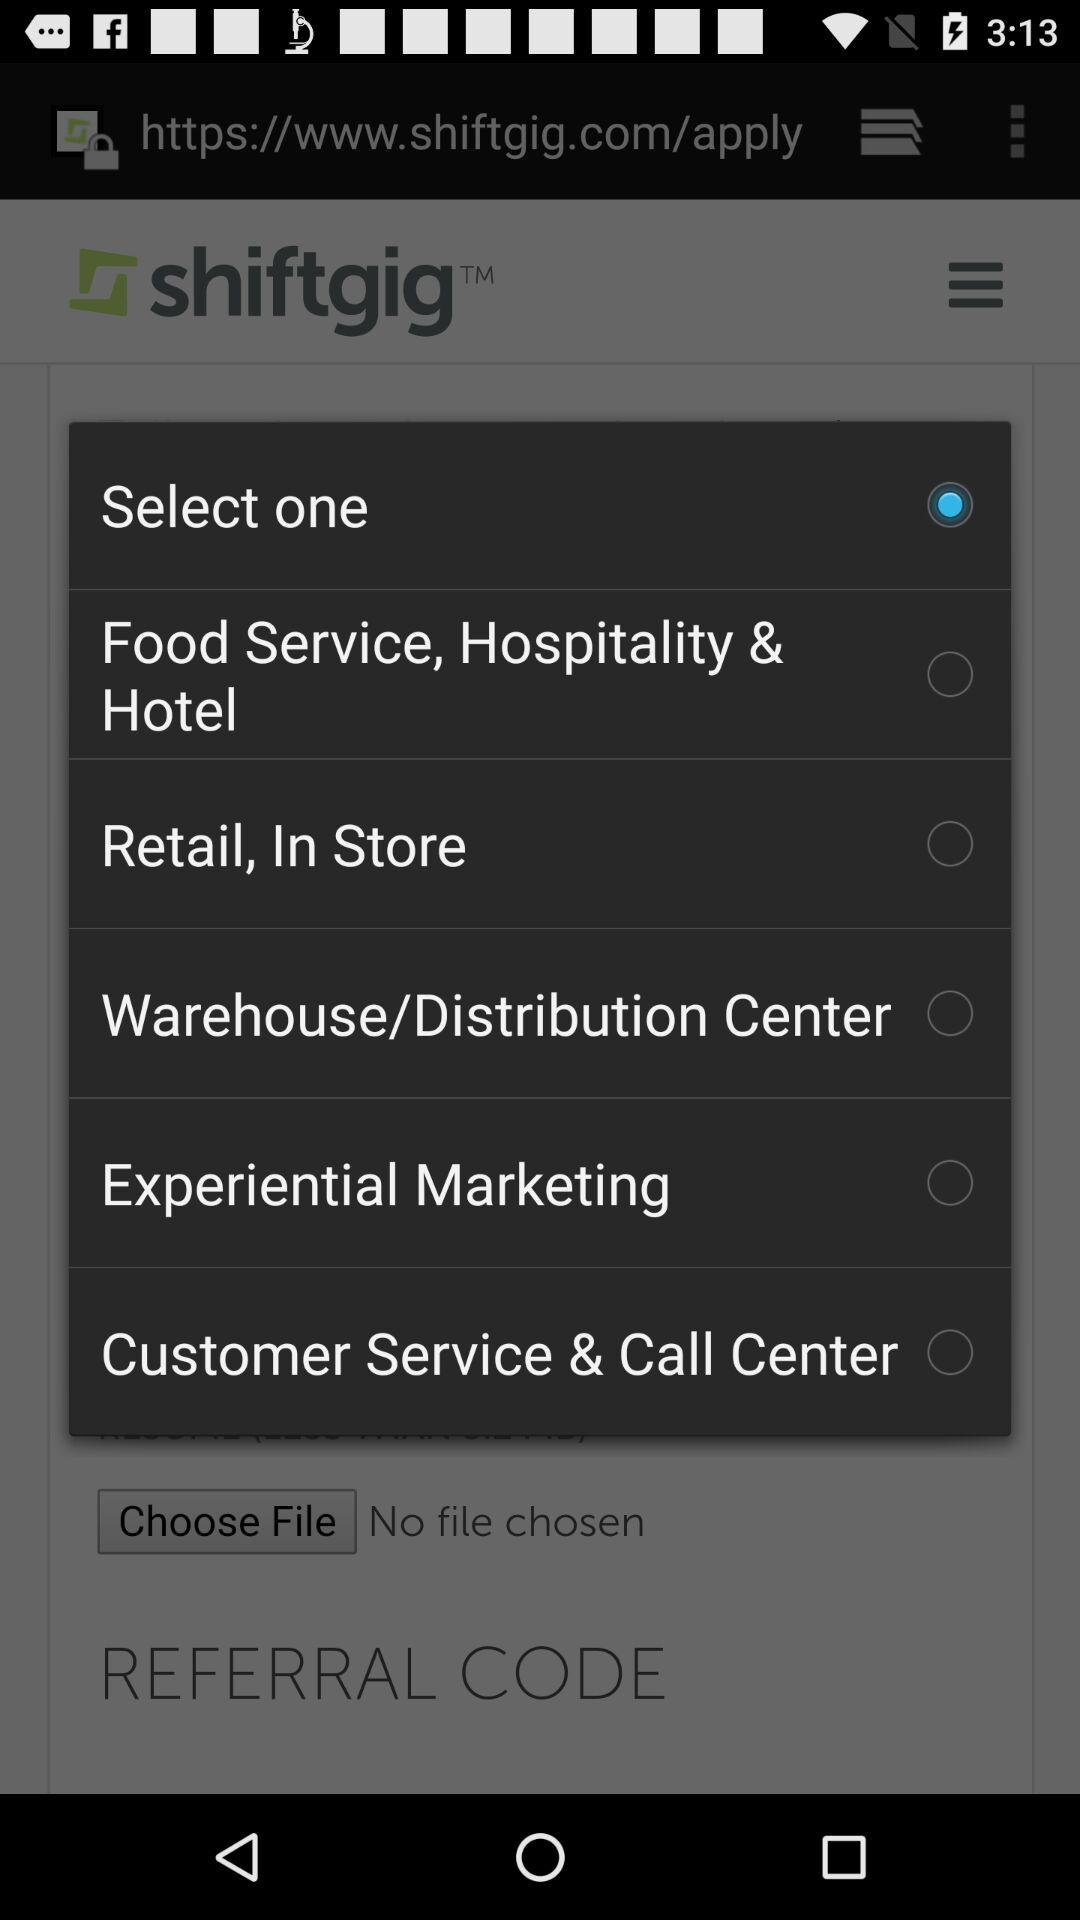Is "Retail, In Store" selected or not? It is not selected. 